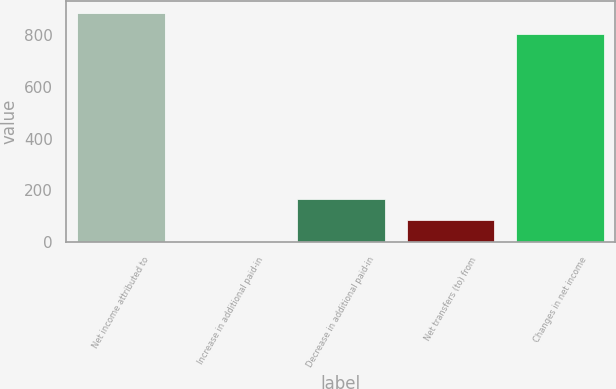Convert chart. <chart><loc_0><loc_0><loc_500><loc_500><bar_chart><fcel>Net income attributed to<fcel>Increase in additional paid-in<fcel>Decrease in additional paid-in<fcel>Net transfers (to) from<fcel>Changes in net income<nl><fcel>886.45<fcel>2.2<fcel>167.3<fcel>84.75<fcel>803.9<nl></chart> 